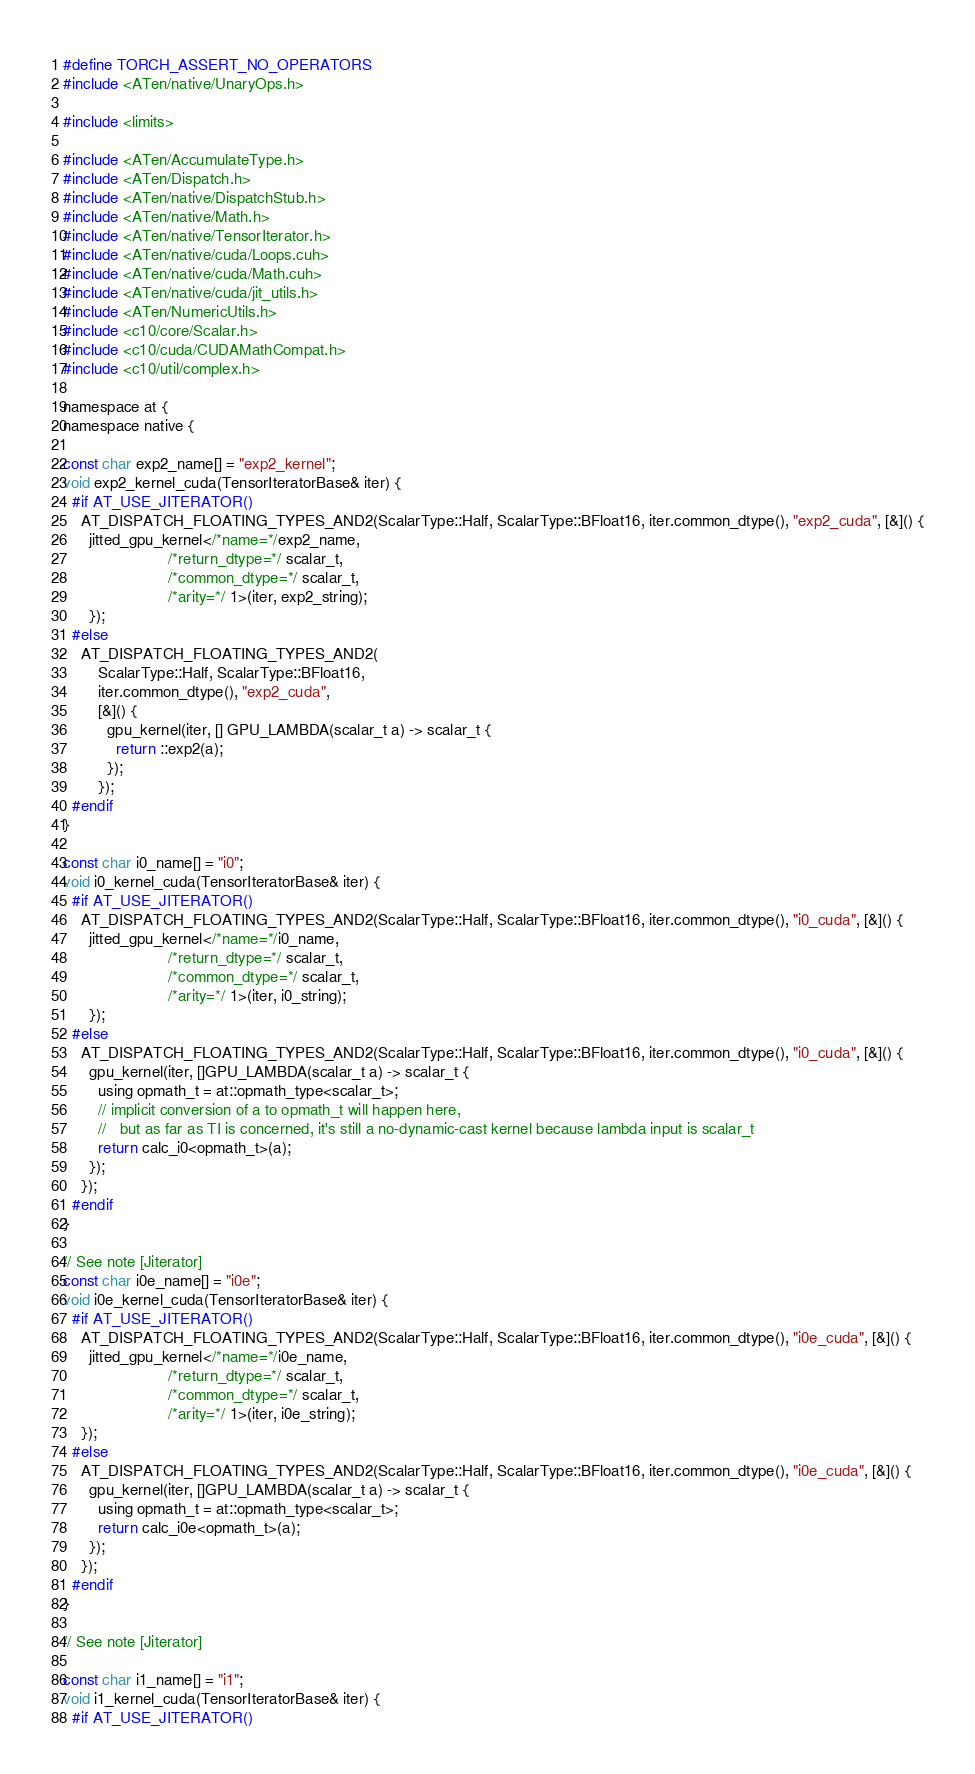Convert code to text. <code><loc_0><loc_0><loc_500><loc_500><_Cuda_>#define TORCH_ASSERT_NO_OPERATORS
#include <ATen/native/UnaryOps.h>

#include <limits>

#include <ATen/AccumulateType.h>
#include <ATen/Dispatch.h>
#include <ATen/native/DispatchStub.h>
#include <ATen/native/Math.h>
#include <ATen/native/TensorIterator.h>
#include <ATen/native/cuda/Loops.cuh>
#include <ATen/native/cuda/Math.cuh>
#include <ATen/native/cuda/jit_utils.h>
#include <ATen/NumericUtils.h>
#include <c10/core/Scalar.h>
#include <c10/cuda/CUDAMathCompat.h>
#include <c10/util/complex.h>

namespace at {
namespace native {

const char exp2_name[] = "exp2_kernel";
void exp2_kernel_cuda(TensorIteratorBase& iter) {
  #if AT_USE_JITERATOR()
    AT_DISPATCH_FLOATING_TYPES_AND2(ScalarType::Half, ScalarType::BFloat16, iter.common_dtype(), "exp2_cuda", [&]() {
      jitted_gpu_kernel</*name=*/exp2_name,
                        /*return_dtype=*/ scalar_t,
                        /*common_dtype=*/ scalar_t,
                        /*arity=*/ 1>(iter, exp2_string);
      });
  #else
    AT_DISPATCH_FLOATING_TYPES_AND2(
        ScalarType::Half, ScalarType::BFloat16,
        iter.common_dtype(), "exp2_cuda",
        [&]() {
          gpu_kernel(iter, [] GPU_LAMBDA(scalar_t a) -> scalar_t {
            return ::exp2(a);
          });
        });
  #endif
}

const char i0_name[] = "i0";
void i0_kernel_cuda(TensorIteratorBase& iter) {
  #if AT_USE_JITERATOR()
    AT_DISPATCH_FLOATING_TYPES_AND2(ScalarType::Half, ScalarType::BFloat16, iter.common_dtype(), "i0_cuda", [&]() {
      jitted_gpu_kernel</*name=*/i0_name,
                        /*return_dtype=*/ scalar_t,
                        /*common_dtype=*/ scalar_t,
                        /*arity=*/ 1>(iter, i0_string);
      });
  #else
    AT_DISPATCH_FLOATING_TYPES_AND2(ScalarType::Half, ScalarType::BFloat16, iter.common_dtype(), "i0_cuda", [&]() {
      gpu_kernel(iter, []GPU_LAMBDA(scalar_t a) -> scalar_t {
        using opmath_t = at::opmath_type<scalar_t>;
        // implicit conversion of a to opmath_t will happen here,
        //   but as far as TI is concerned, it's still a no-dynamic-cast kernel because lambda input is scalar_t
        return calc_i0<opmath_t>(a);
      });
    });
  #endif
}

// See note [Jiterator]
const char i0e_name[] = "i0e";
void i0e_kernel_cuda(TensorIteratorBase& iter) {
  #if AT_USE_JITERATOR()
    AT_DISPATCH_FLOATING_TYPES_AND2(ScalarType::Half, ScalarType::BFloat16, iter.common_dtype(), "i0e_cuda", [&]() {
      jitted_gpu_kernel</*name=*/i0e_name,
                        /*return_dtype=*/ scalar_t,
                        /*common_dtype=*/ scalar_t,
                        /*arity=*/ 1>(iter, i0e_string);
    });
  #else
    AT_DISPATCH_FLOATING_TYPES_AND2(ScalarType::Half, ScalarType::BFloat16, iter.common_dtype(), "i0e_cuda", [&]() {
      gpu_kernel(iter, []GPU_LAMBDA(scalar_t a) -> scalar_t {
        using opmath_t = at::opmath_type<scalar_t>;
        return calc_i0e<opmath_t>(a);
      });
    });
  #endif
}

// See note [Jiterator]

const char i1_name[] = "i1";
void i1_kernel_cuda(TensorIteratorBase& iter) {
  #if AT_USE_JITERATOR()</code> 